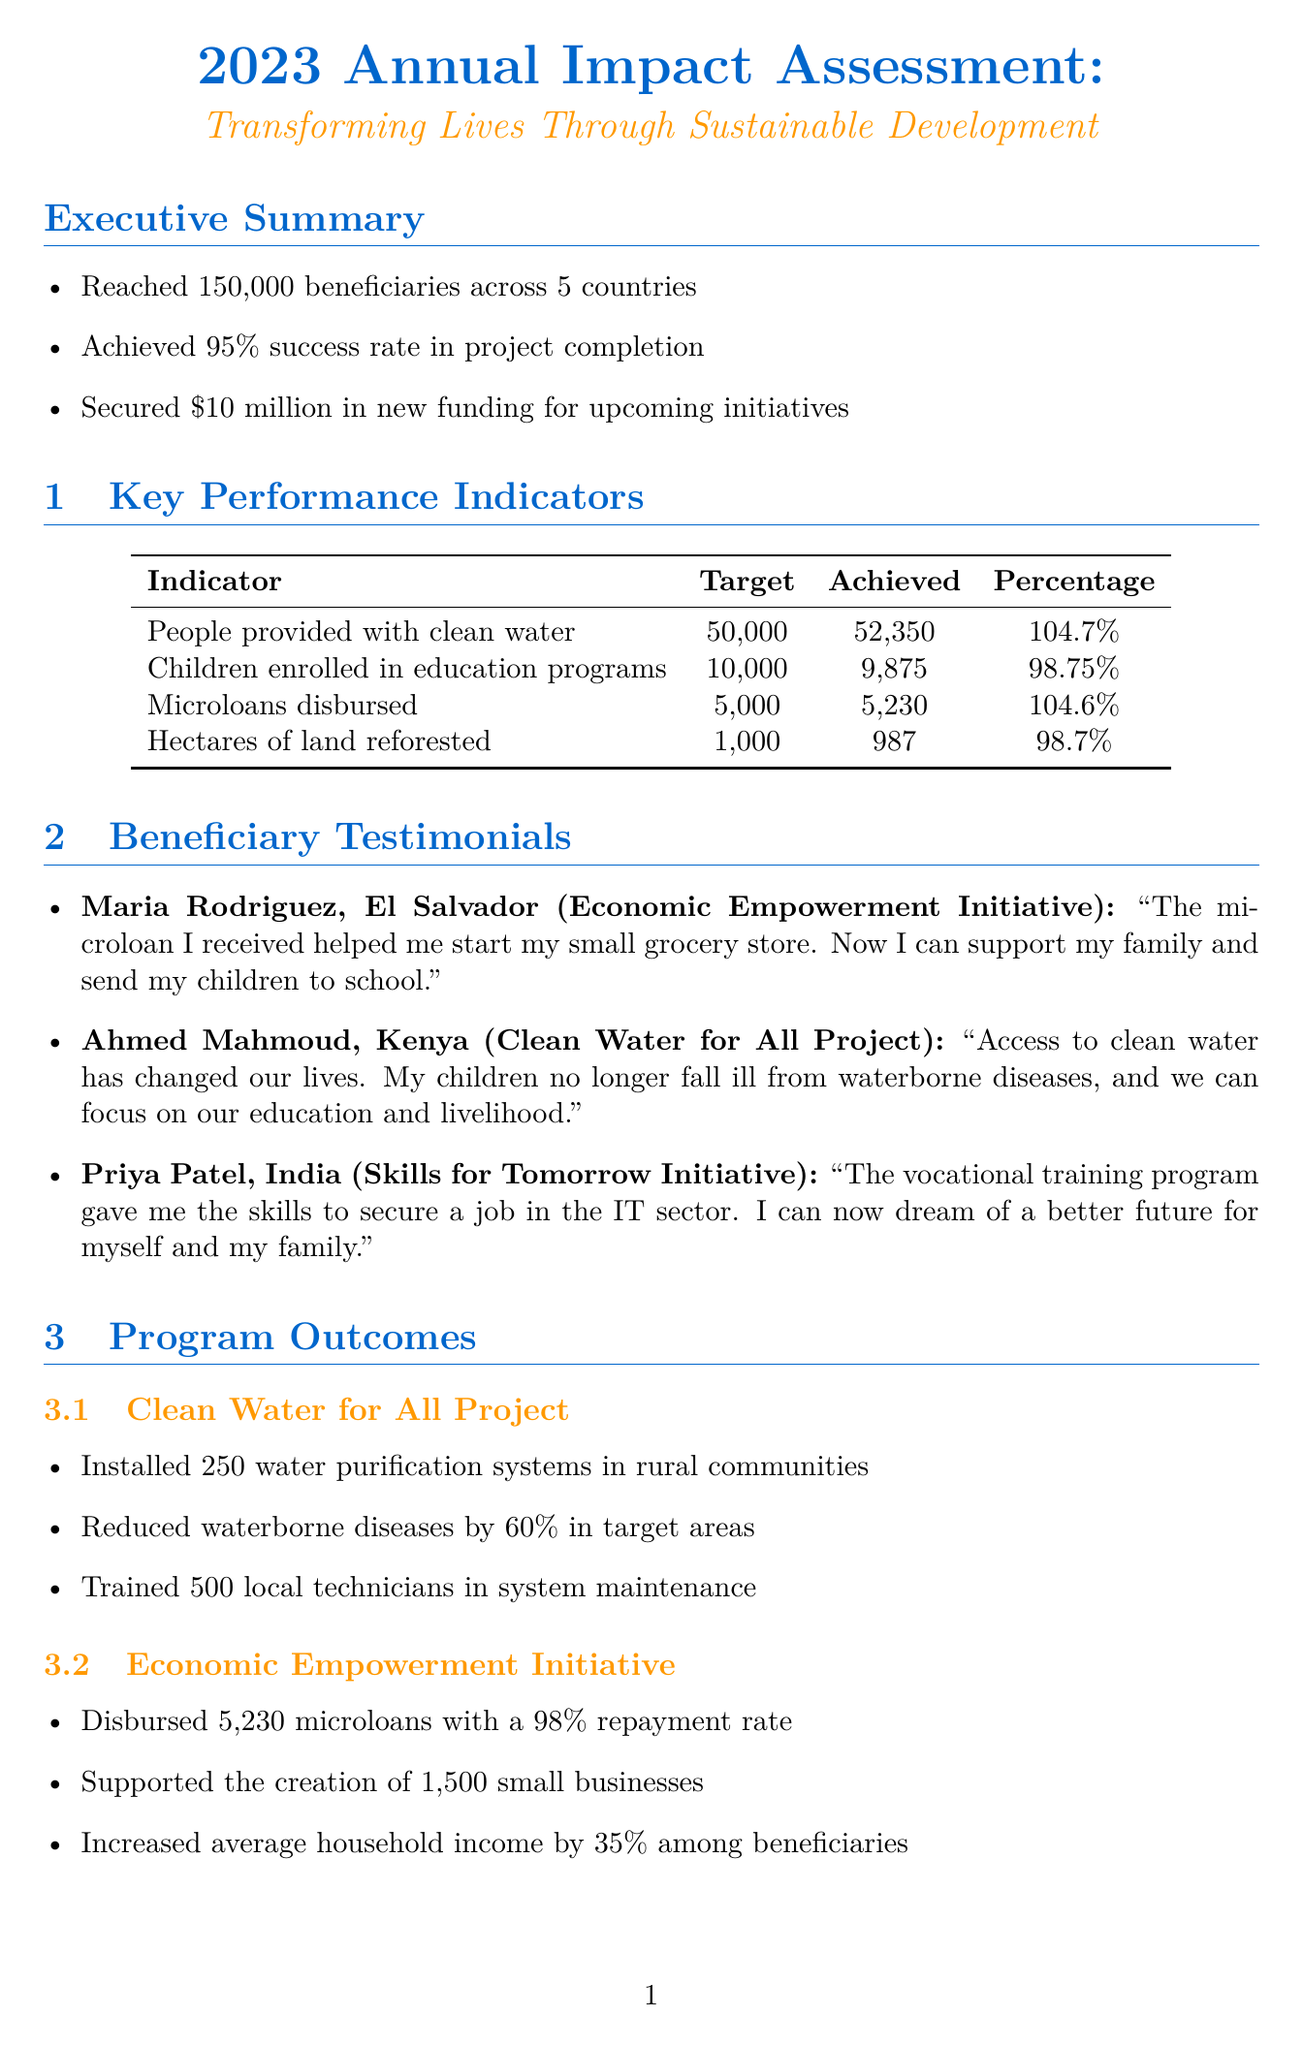What is the title of the report? The title of the report is explicitly stated in the document.
Answer: 2023 Annual Impact Assessment: Transforming Lives Through Sustainable Development How many beneficiaries were reached? The number of beneficiaries reached is highlighted in the executive summary.
Answer: 150,000 What percentage of the microloans disbursed were repaid? The repayment rate for microloans is presented in the outcomes of the Economic Empowerment Initiative.
Answer: 98% What is the proposed budget for the Climate Resilience Program? The proposed budget is given in the description of future initiatives section of the document.
Answer: $15,000,000 Which program installed water purification systems? The program responsible for installing water purification systems is mentioned in the Program Outcomes section.
Answer: Clean Water for All Project How many new schools were built in the Education for All Campaign? The number of schools built is specified in the outcomes of the Education for All Campaign.
Answer: 20 What is the average percentage increase in household income among beneficiaries? The increase in average household income is included in the program outcomes.
Answer: 35% Which organization is NOT listed as a partner organization? By noting the organizations listed, we can identify any that are not mentioned in the document.
Answer: None (all listed are partners) 